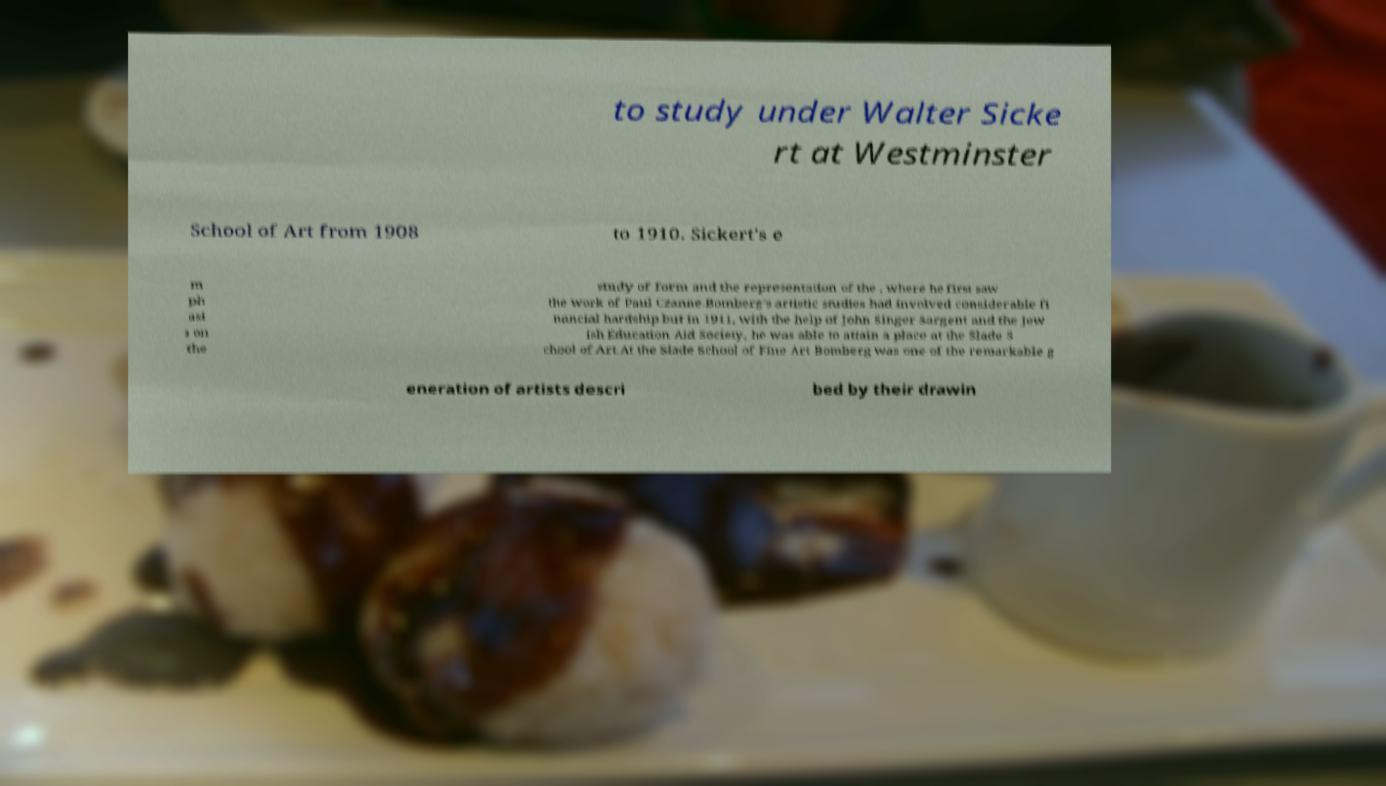Please identify and transcribe the text found in this image. to study under Walter Sicke rt at Westminster School of Art from 1908 to 1910. Sickert's e m ph asi s on the study of form and the representation of the , where he first saw the work of Paul Czanne.Bomberg's artistic studies had involved considerable fi nancial hardship but in 1911, with the help of John Singer Sargent and the Jew ish Education Aid Society, he was able to attain a place at the Slade S chool of Art.At the Slade School of Fine Art Bomberg was one of the remarkable g eneration of artists descri bed by their drawin 